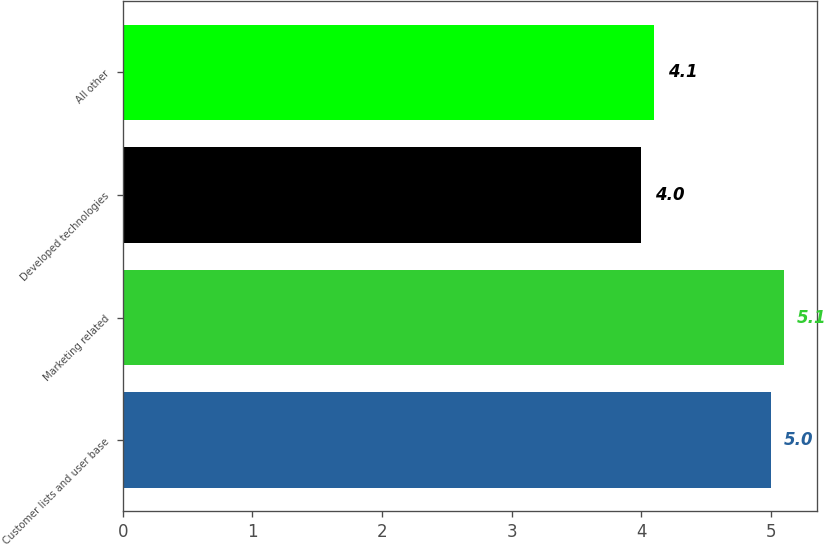Convert chart to OTSL. <chart><loc_0><loc_0><loc_500><loc_500><bar_chart><fcel>Customer lists and user base<fcel>Marketing related<fcel>Developed technologies<fcel>All other<nl><fcel>5<fcel>5.1<fcel>4<fcel>4.1<nl></chart> 